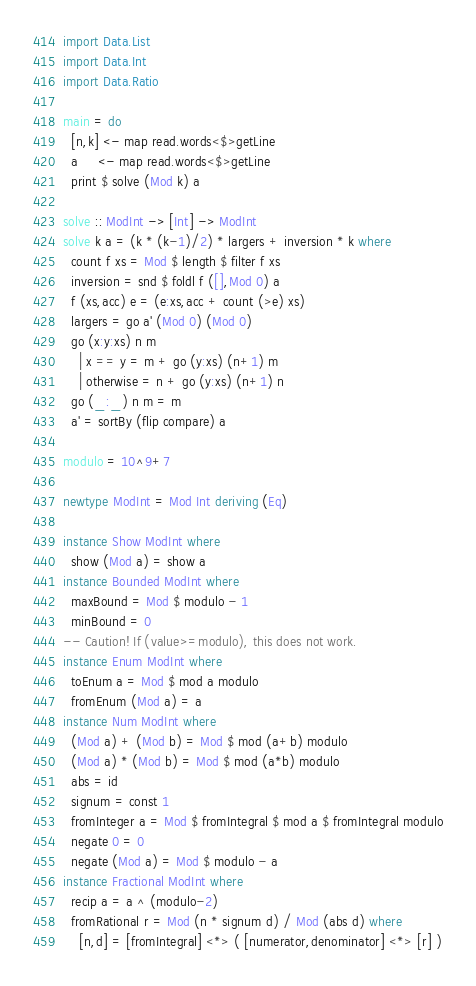<code> <loc_0><loc_0><loc_500><loc_500><_Haskell_>import Data.List
import Data.Int
import Data.Ratio

main = do
  [n,k] <- map read.words<$>getLine
  a     <- map read.words<$>getLine
  print $ solve (Mod k) a

solve :: ModInt -> [Int] -> ModInt
solve k a = (k * (k-1)/2) * largers + inversion * k where
  count f xs = Mod $ length $ filter f xs
  inversion = snd $ foldl f ([],Mod 0) a
  f (xs,acc) e = (e:xs,acc + count (>e) xs)
  largers = go a' (Mod 0) (Mod 0)
  go (x:y:xs) n m
    | x == y = m + go (y:xs) (n+1) m
    | otherwise = n + go (y:xs) (n+1) n
  go (_:_) n m = m
  a' = sortBy (flip compare) a

modulo = 10^9+7

newtype ModInt = Mod Int deriving (Eq)

instance Show ModInt where
  show (Mod a) = show a
instance Bounded ModInt where
  maxBound = Mod $ modulo - 1
  minBound = 0
-- Caution! If (value>=modulo), this does not work.
instance Enum ModInt where
  toEnum a = Mod $ mod a modulo
  fromEnum (Mod a) = a
instance Num ModInt where
  (Mod a) + (Mod b) = Mod $ mod (a+b) modulo
  (Mod a) * (Mod b) = Mod $ mod (a*b) modulo
  abs = id
  signum = const 1
  fromInteger a = Mod $ fromIntegral $ mod a $ fromIntegral modulo
  negate 0 = 0
  negate (Mod a) = Mod $ modulo - a
instance Fractional ModInt where
  recip a = a ^ (modulo-2)
  fromRational r = Mod (n * signum d) / Mod (abs d) where
    [n,d] = [fromIntegral] <*> ( [numerator,denominator] <*> [r] )
</code> 